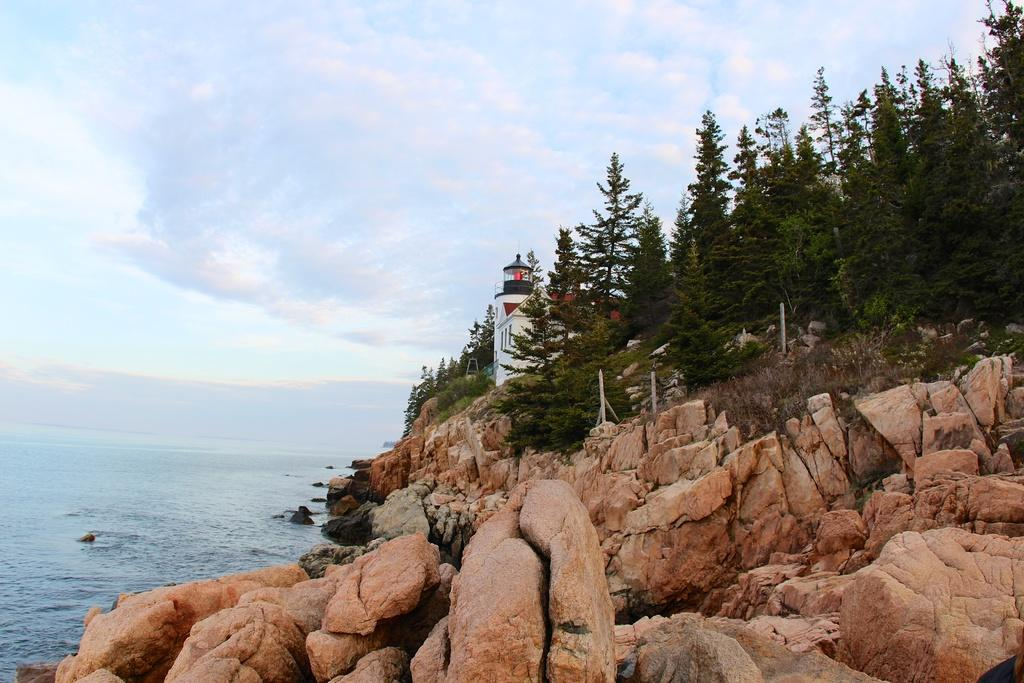What type of structure is present in the image? There is a building in the image. What natural elements can be seen in the image? There are rocks, trees, and water visible in the image. What is visible in the background of the image? The sky is visible in the background of the image. What can be observed in the sky? Clouds are present in the sky. What type of corn is growing near the building in the image? There is no corn present in the image; it features a building, rocks, trees, water, and clouds. What is the tendency of spiders in the image? There are no spiders present in the image, so it is not possible to determine their tendencies. 